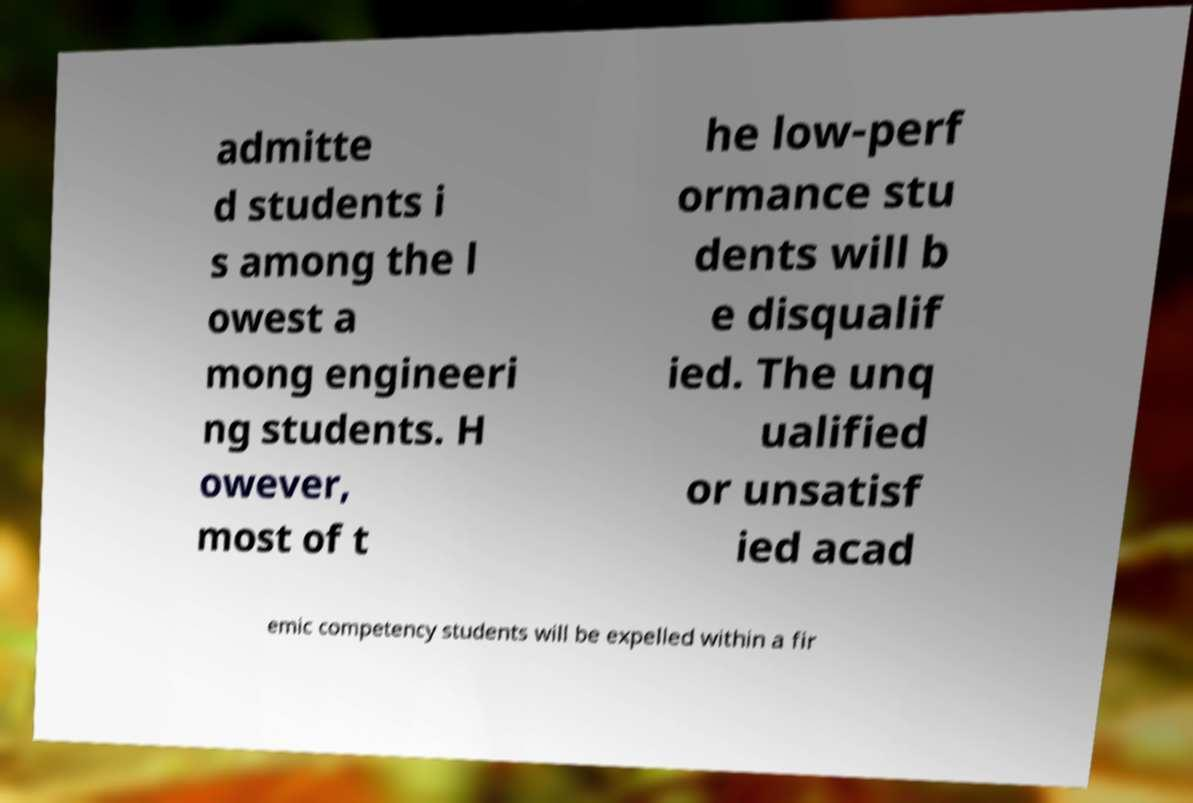What messages or text are displayed in this image? I need them in a readable, typed format. admitte d students i s among the l owest a mong engineeri ng students. H owever, most of t he low-perf ormance stu dents will b e disqualif ied. The unq ualified or unsatisf ied acad emic competency students will be expelled within a fir 